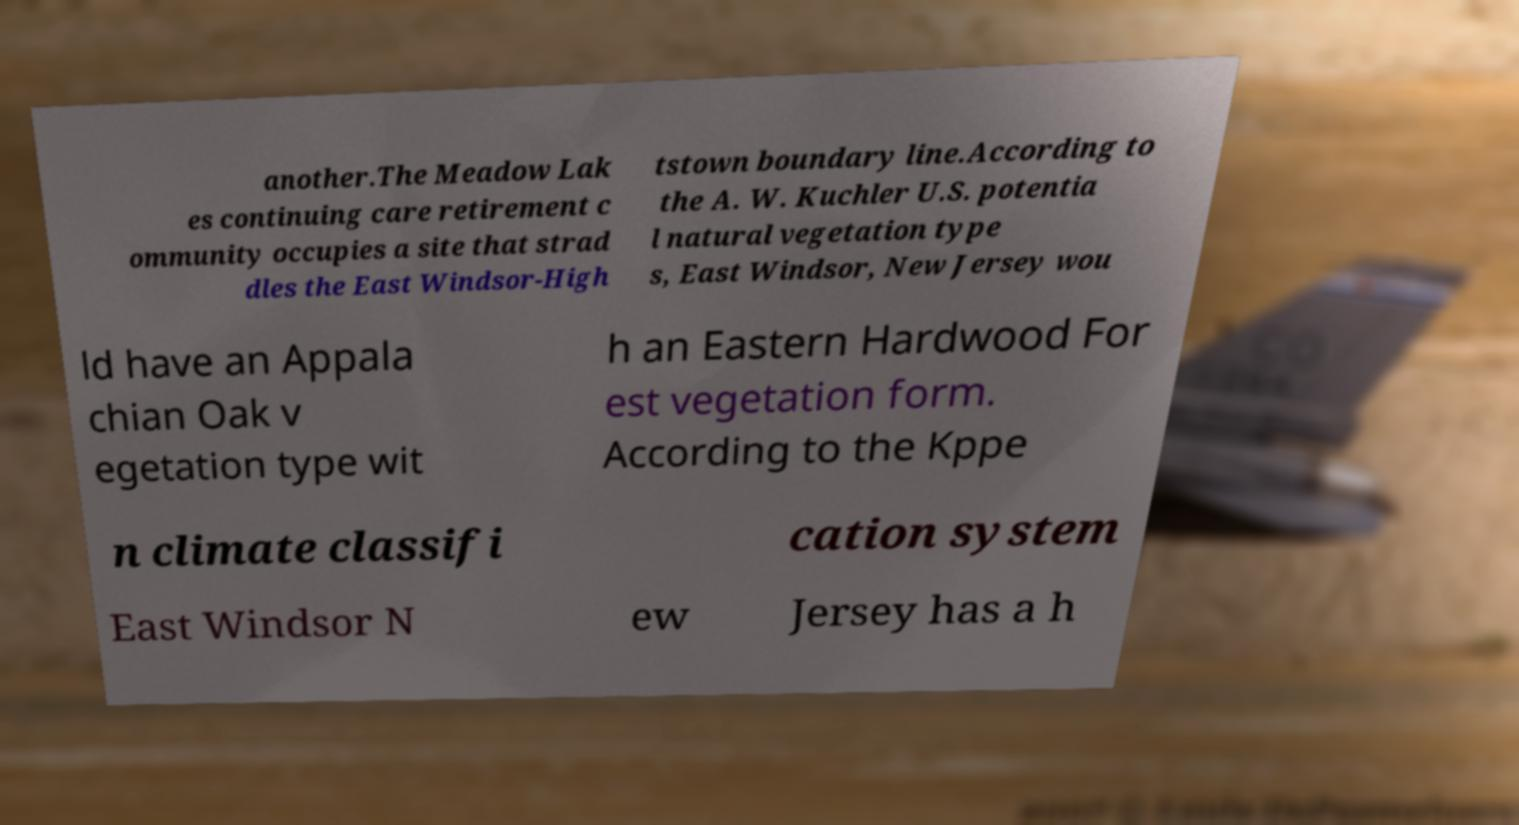What messages or text are displayed in this image? I need them in a readable, typed format. another.The Meadow Lak es continuing care retirement c ommunity occupies a site that strad dles the East Windsor-High tstown boundary line.According to the A. W. Kuchler U.S. potentia l natural vegetation type s, East Windsor, New Jersey wou ld have an Appala chian Oak v egetation type wit h an Eastern Hardwood For est vegetation form. According to the Kppe n climate classifi cation system East Windsor N ew Jersey has a h 